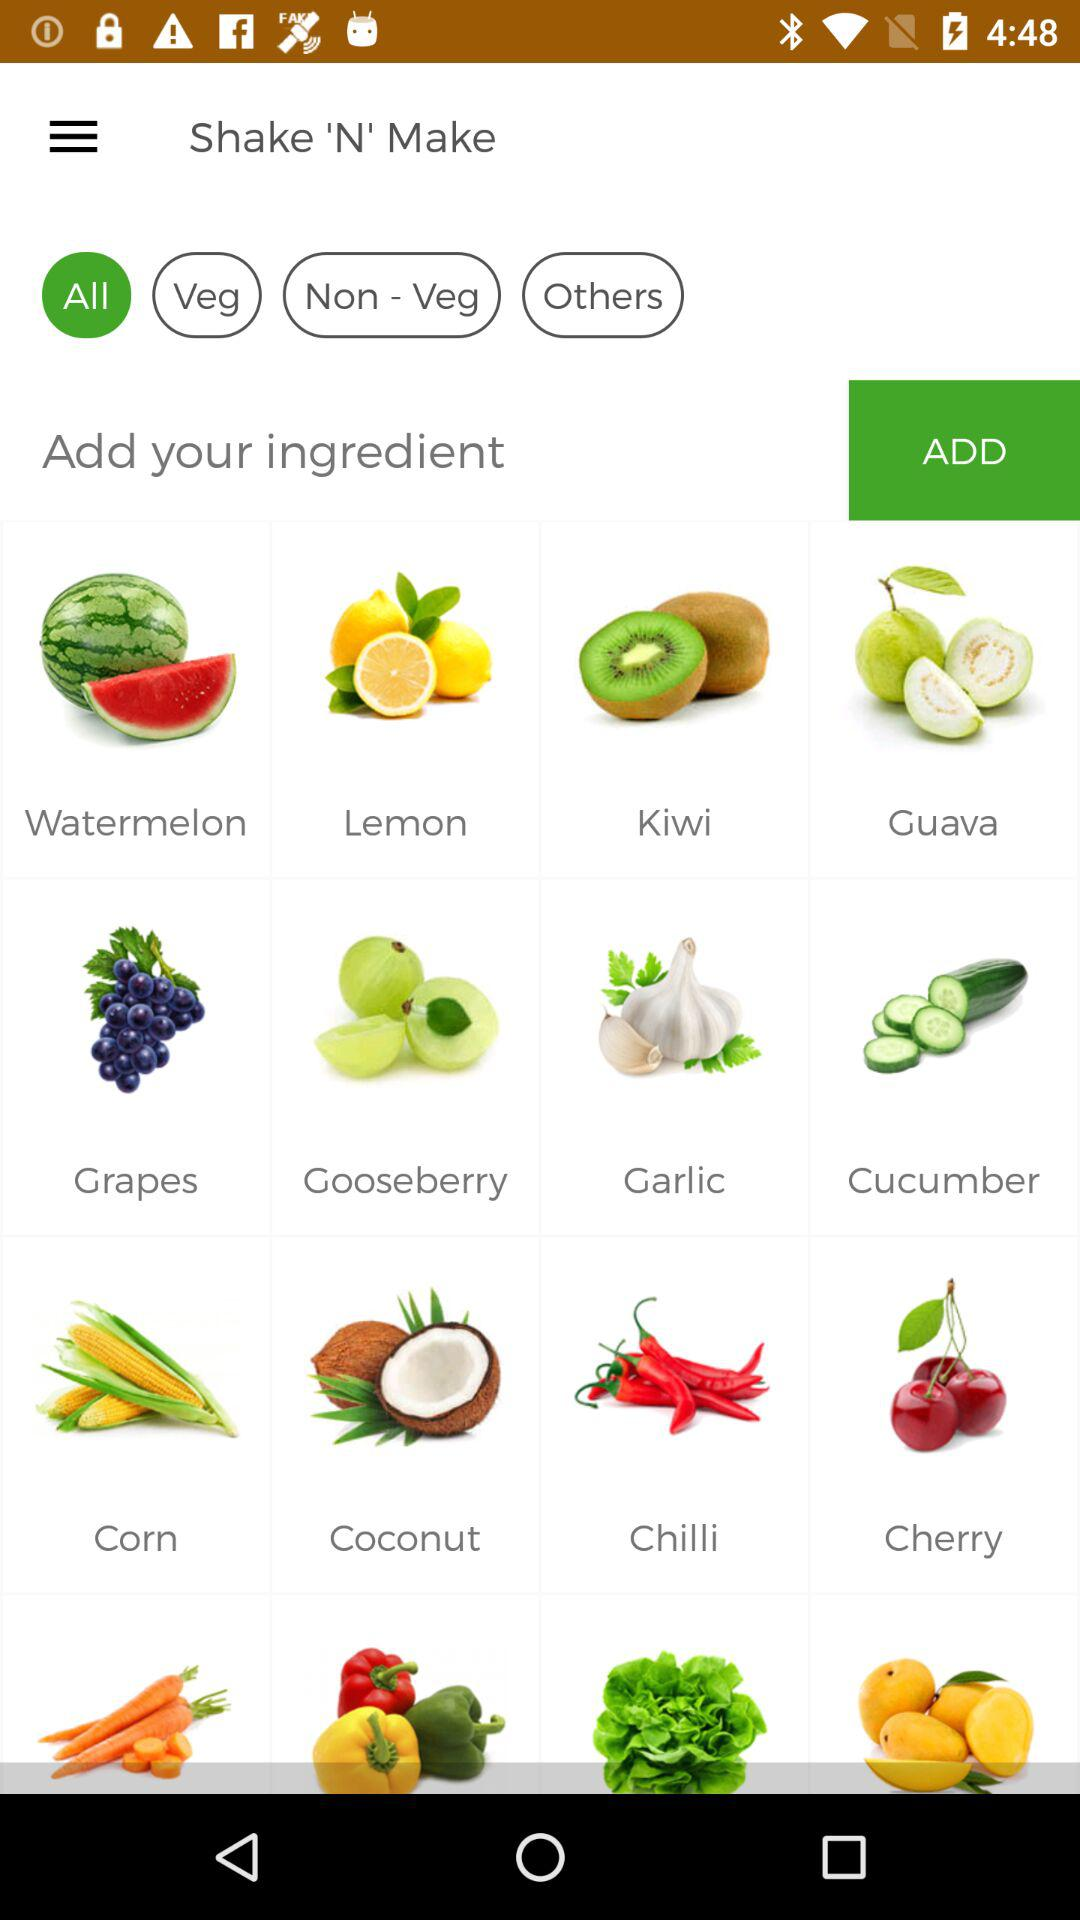What is the name of the application? The name of the application is "Shake 'N' Make". 